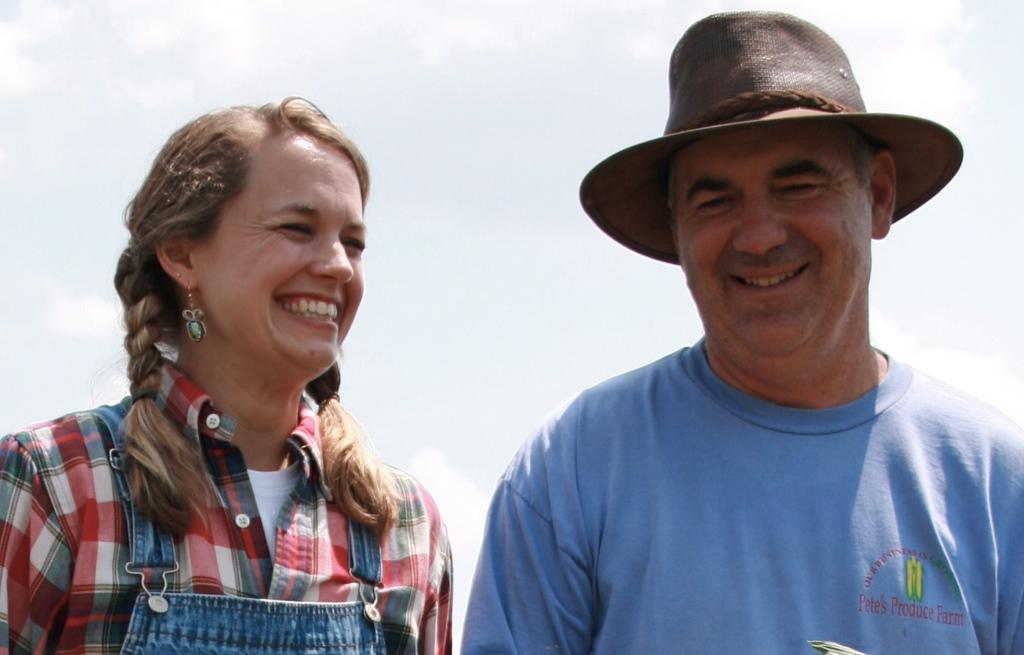Where was the image taken? The image is taken outdoors. What can be seen in the sky in the image? There is a sky with clouds visible in the image. How many people are in the image? There is a man and a woman in the image. What is the facial expression of the man and the woman? Both the man and the woman have smiling faces. How many beans are being used as a prop in the image? There are no beans present in the image. Can you see any mice running around in the image? There are no mice visible in the image. 